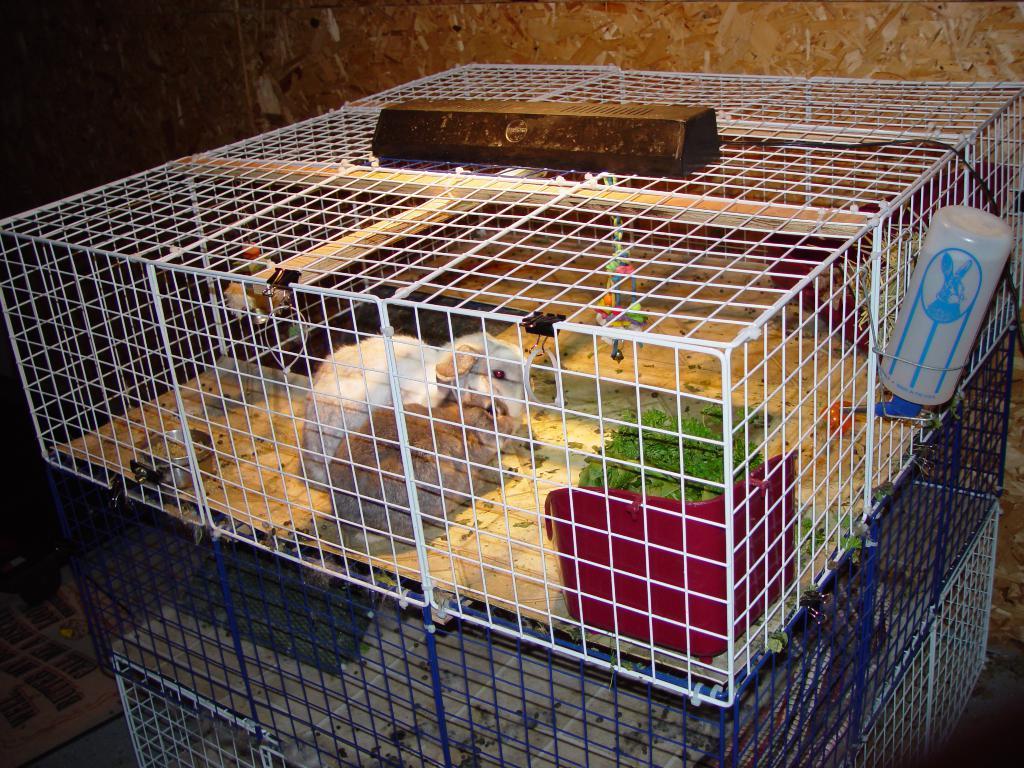Can you describe this image briefly? In this image we can see a rectangular shape white color net, inside it mouses are present and some green leafs are there and to the right side of the box one white color container is attached. 